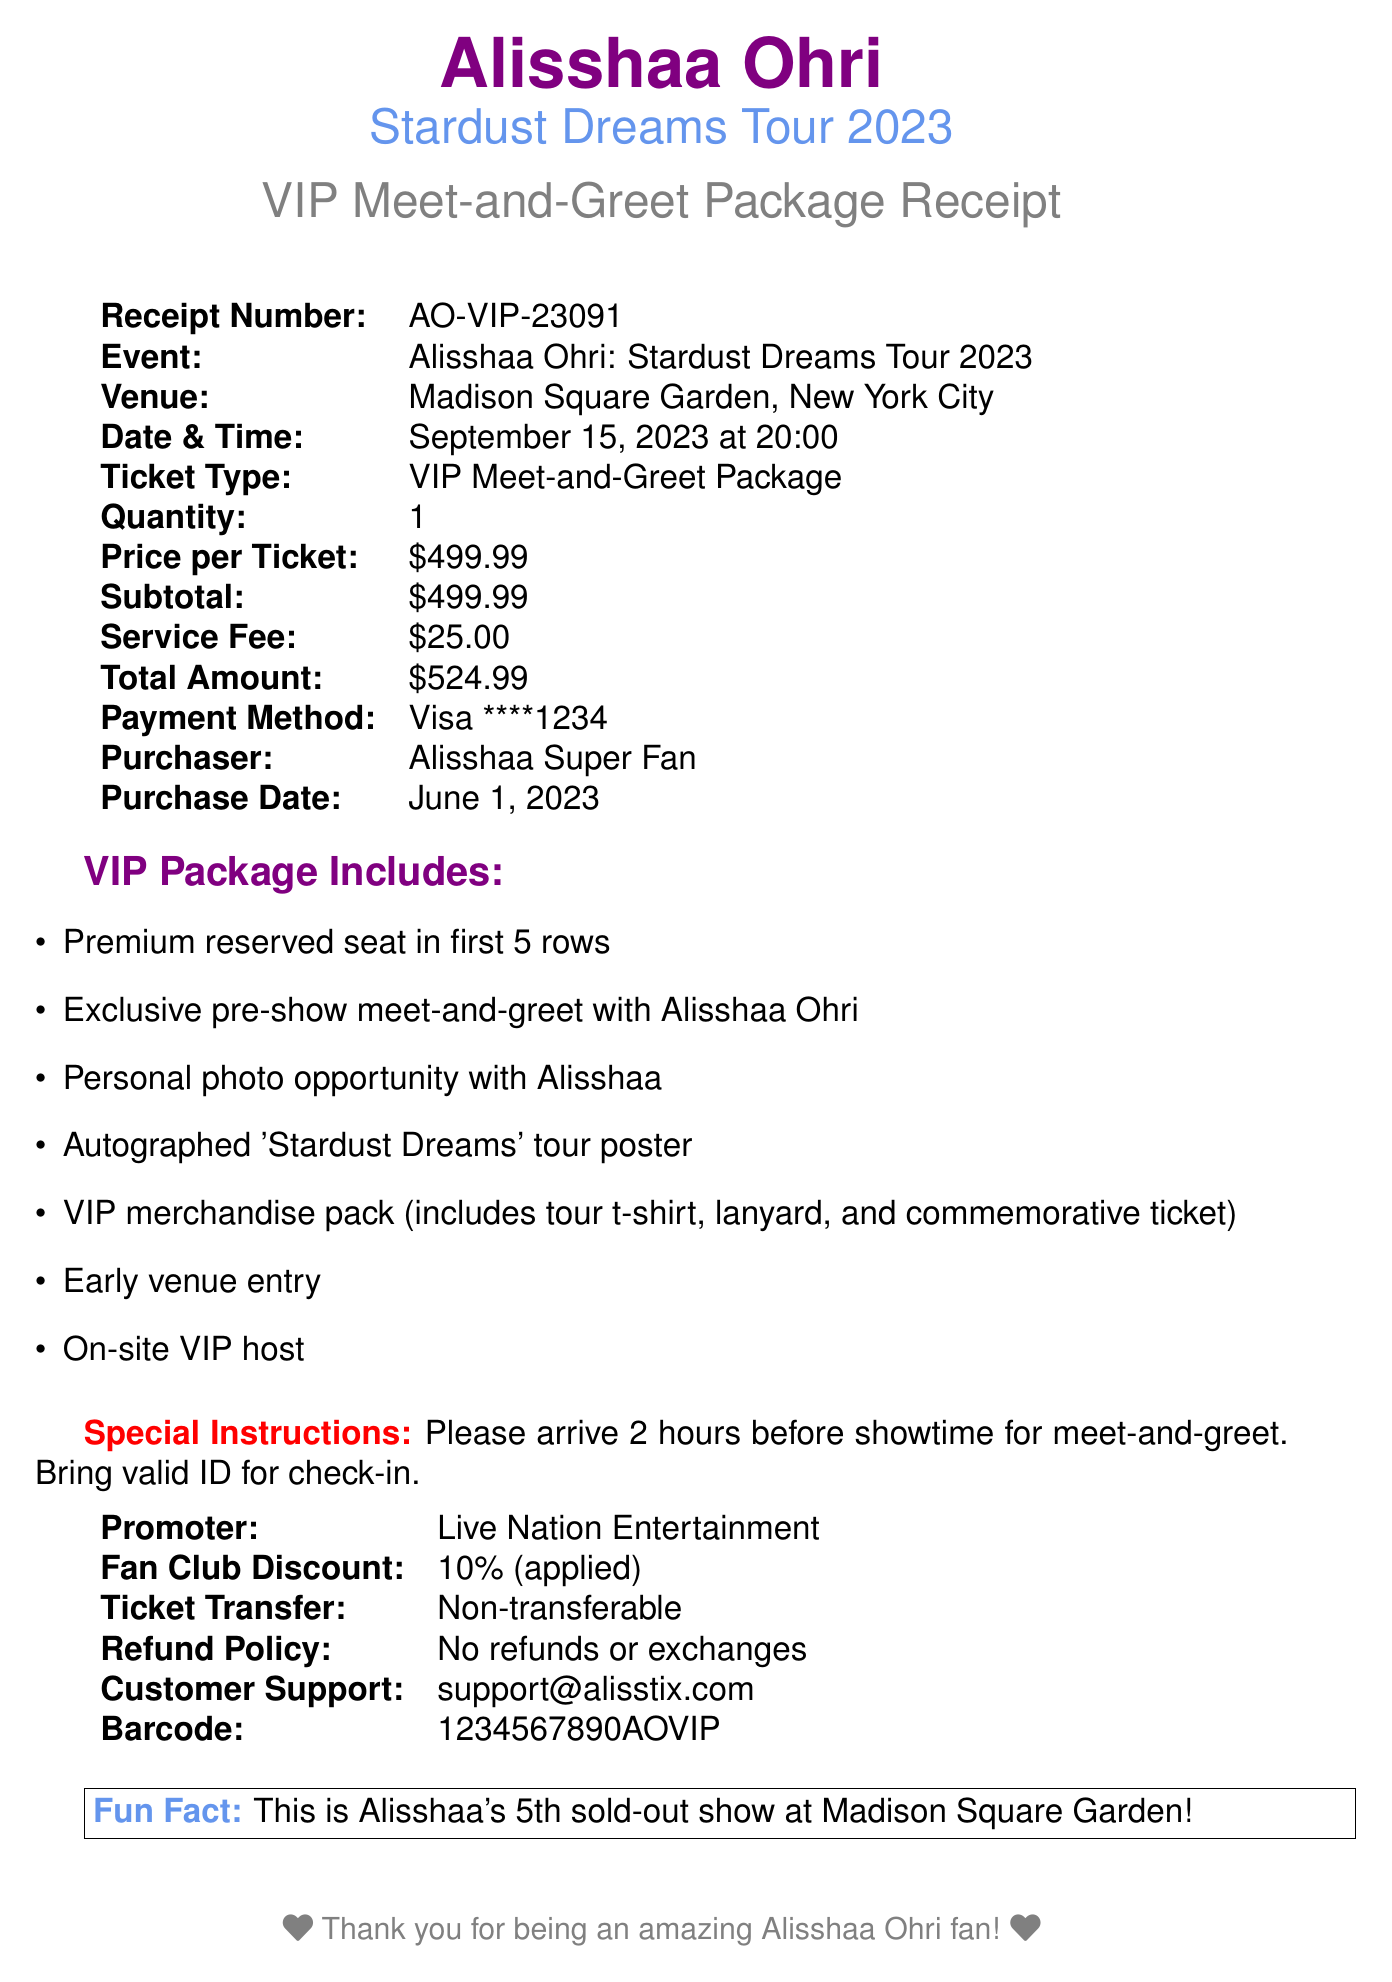What is the receipt number? The receipt number is stated at the top of the document under "Receipt Number."
Answer: AO-VIP-23091 Where is the concert being held? The venue for the concert is specified in the document as "Venue."
Answer: Madison Square Garden, New York City What is the price of the VIP package? The price per ticket is mentioned in the table as "Price per Ticket."
Answer: $499.99 When was the purchase made? The purchase date is provided in the document under "Purchase Date."
Answer: June 1, 2023 How much is the total amount charged? The total amount can be found in the receipt table under "Total Amount."
Answer: $524.99 What special instructions are provided? The special instructions are listed in the document for arriving early and checking in.
Answer: Please arrive 2 hours before showtime for meet-and-greet. Bring valid ID for check-in How many items are included in the VIP package? The VIP package includes multiple items listed in the bullet points.
Answer: 7 What is the promoter's name? The promoter's name is found in the "Promoter" section of the document.
Answer: Live Nation Entertainment Is the ticket transferable? The document states the policy regarding ticket transfer, found in the appropriate section.
Answer: Non-transferable 